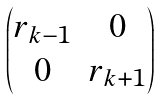<formula> <loc_0><loc_0><loc_500><loc_500>\begin{pmatrix} r _ { k - 1 } & 0 \\ 0 & r _ { k + 1 } \end{pmatrix}</formula> 